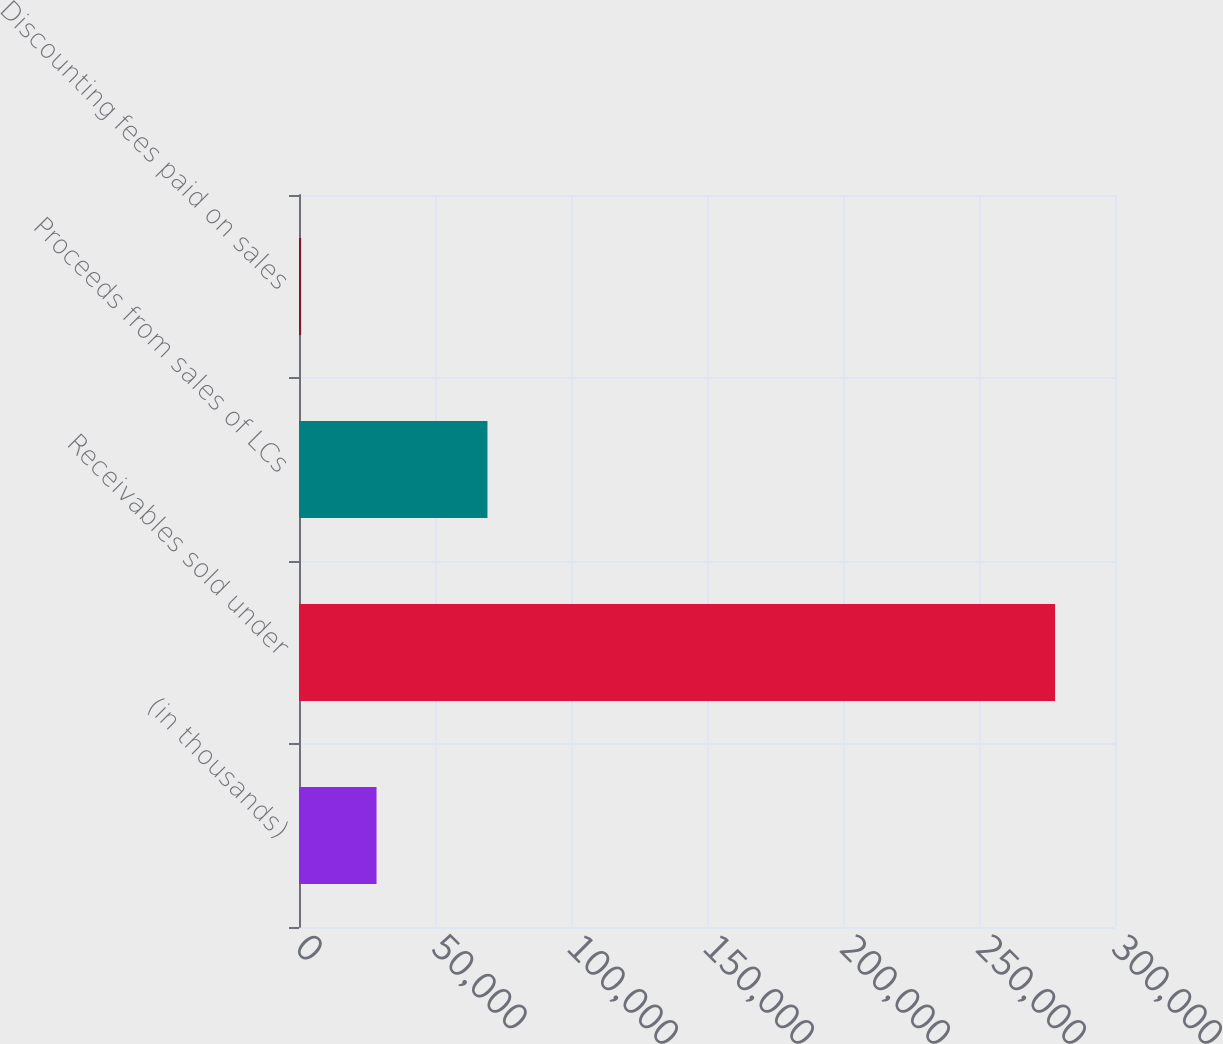<chart> <loc_0><loc_0><loc_500><loc_500><bar_chart><fcel>(in thousands)<fcel>Receivables sold under<fcel>Proceeds from sales of LCs<fcel>Discounting fees paid on sales<nl><fcel>28505.2<fcel>277960<fcel>69286<fcel>788<nl></chart> 